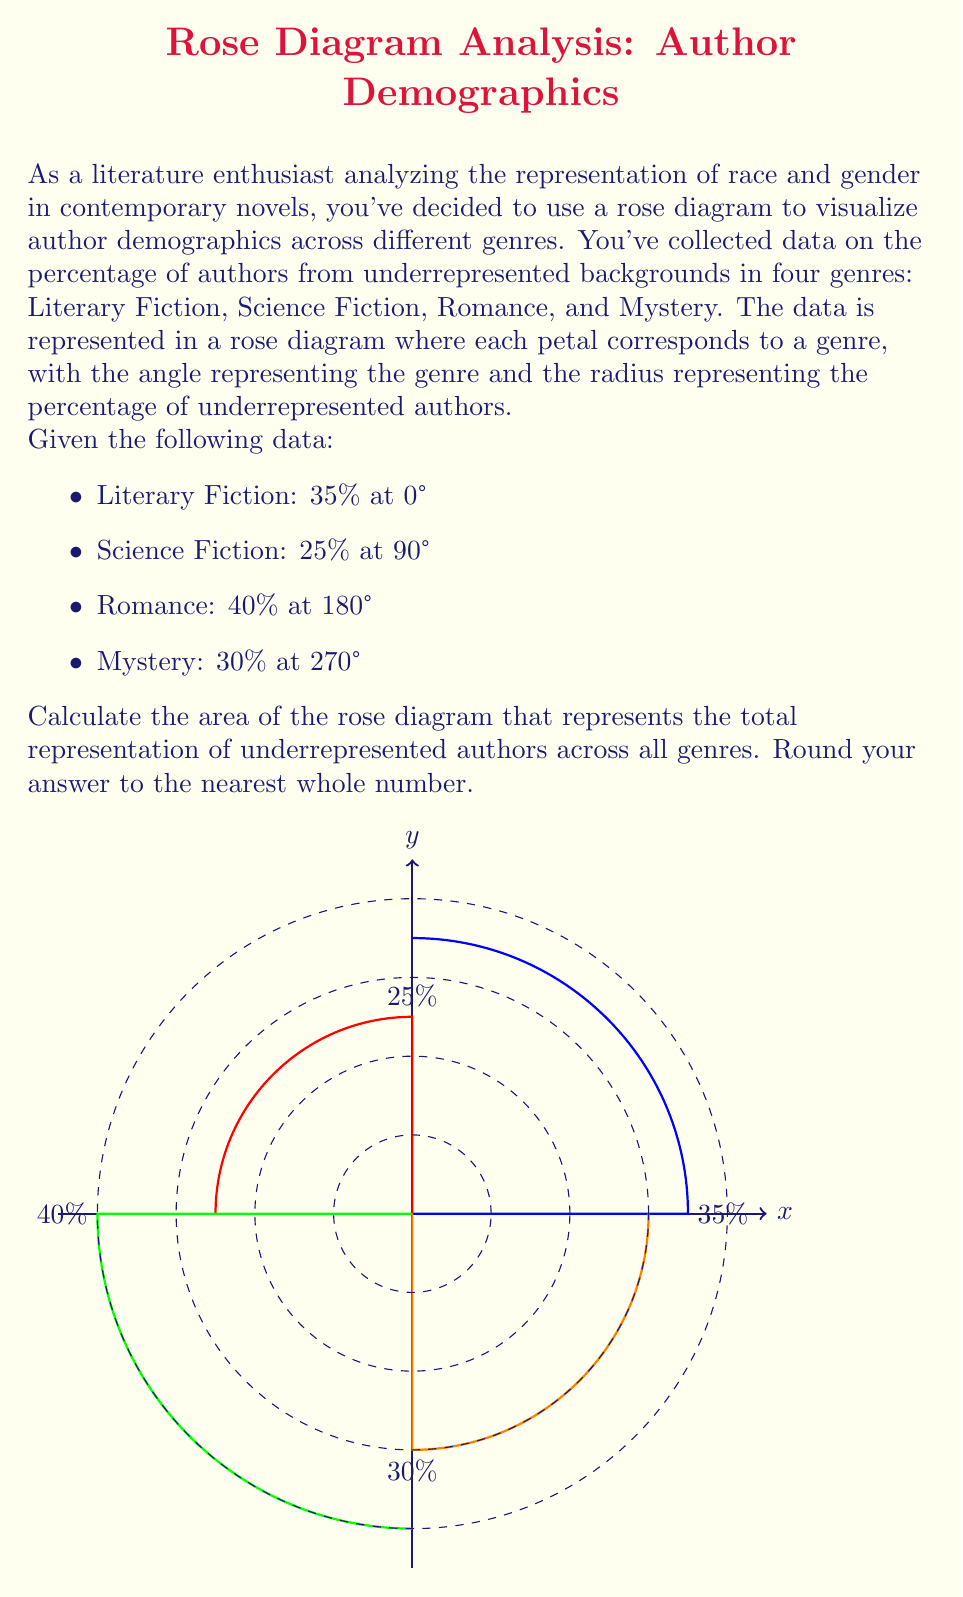Provide a solution to this math problem. To solve this problem, we'll use the formula for the area of a rose petal in polar coordinates and sum the areas for all four genres. The steps are as follows:

1) The general formula for the area of a rose petal is:
   $$A = \frac{1}{2} \int_{0}^{\frac{\pi}{2}} r^2 d\theta$$
   where $r$ is the radius (percentage in this case) and $\theta$ is the angle.

2) For each genre, we'll use $r^2 = a^2 \sin^2(n\theta)$ or $r^2 = a^2 \cos^2(n\theta)$, where $a$ is the given percentage and $n=1$ for our case.

3) Literary Fiction (0°): $r^2 = 35^2 \cos^2(\theta)$
   $$A_1 = \frac{1}{2} \int_{0}^{\frac{\pi}{2}} 35^2 \cos^2(\theta) d\theta = \frac{35^2}{4} \cdot \frac{\pi}{2} = 481.54$$

4) Science Fiction (90°): $r^2 = 25^2 \sin^2(\theta)$
   $$A_2 = \frac{1}{2} \int_{0}^{\frac{\pi}{2}} 25^2 \sin^2(\theta) d\theta = \frac{25^2}{4} \cdot \frac{\pi}{2} = 245.44$$

5) Romance (180°): $r^2 = 40^2 \sin^2(\theta)$
   $$A_3 = \frac{1}{2} \int_{0}^{\frac{\pi}{2}} 40^2 \sin^2(\theta) d\theta = \frac{40^2}{4} \cdot \frac{\pi}{2} = 628.32$$

6) Mystery (270°): $r^2 = 30^2 \cos^2(\theta)$
   $$A_4 = \frac{1}{2} \int_{0}^{\frac{\pi}{2}} 30^2 \cos^2(\theta) d\theta = \frac{30^2}{4} \cdot \frac{\pi}{2} = 353.43$$

7) Sum all areas:
   $$A_{total} = A_1 + A_2 + A_3 + A_4 = 481.54 + 245.44 + 628.32 + 353.43 = 1708.73$$

8) Rounding to the nearest whole number: 1709
Answer: 1709 